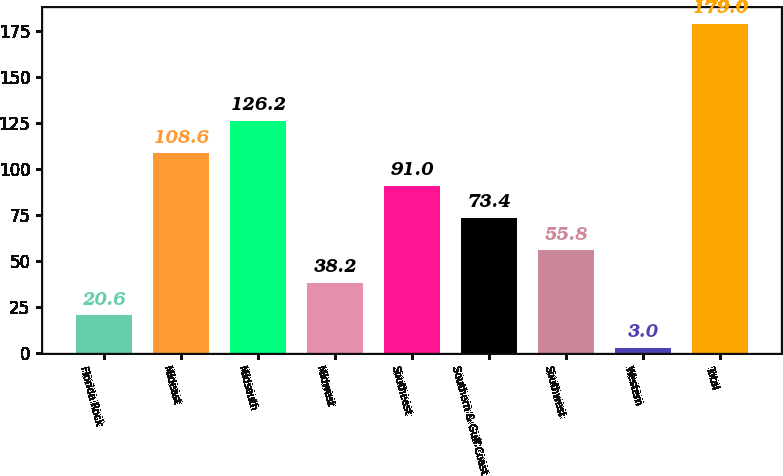Convert chart. <chart><loc_0><loc_0><loc_500><loc_500><bar_chart><fcel>Florida Rock<fcel>Mideast<fcel>Midsouth<fcel>Midwest<fcel>Southeast<fcel>Southern & Gulf Coast<fcel>Southwest<fcel>Western<fcel>Total<nl><fcel>20.6<fcel>108.6<fcel>126.2<fcel>38.2<fcel>91<fcel>73.4<fcel>55.8<fcel>3<fcel>179<nl></chart> 